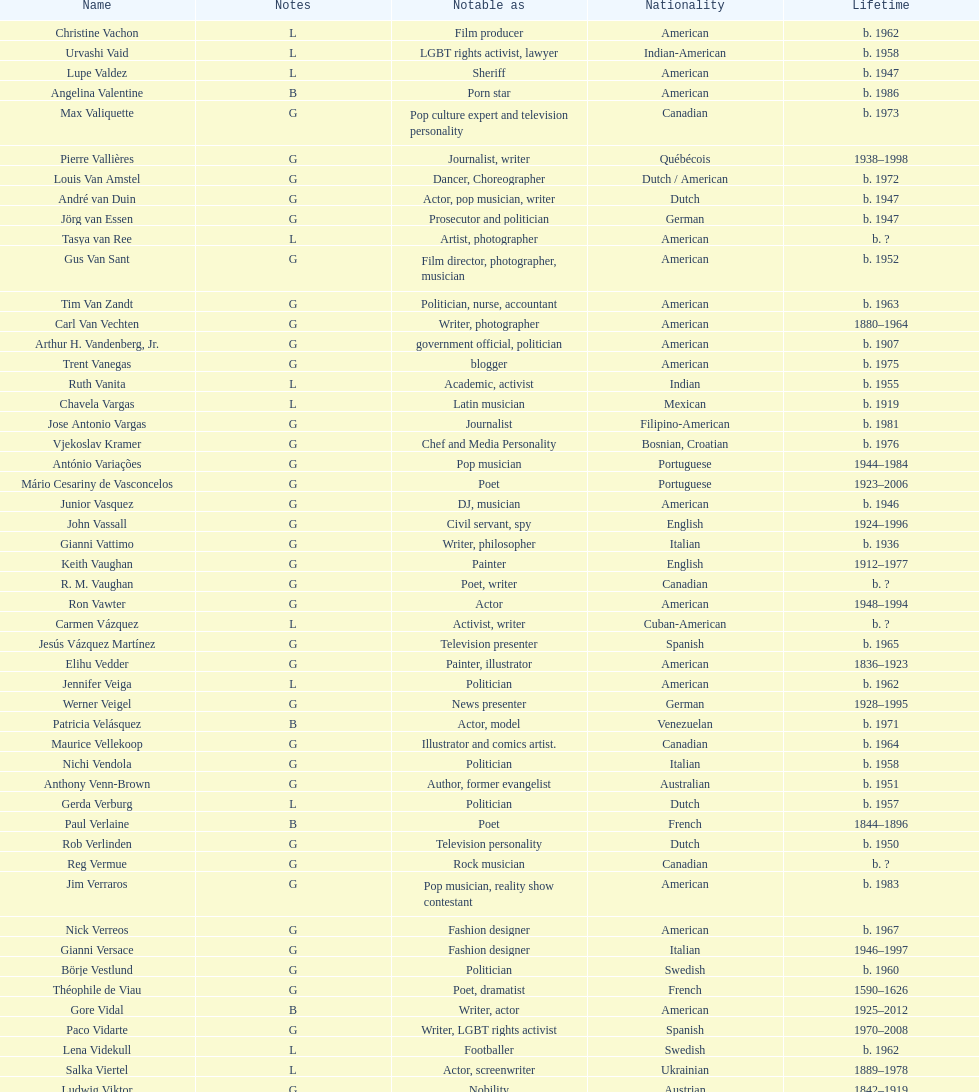How old was pierre vallieres before he died? 60. 